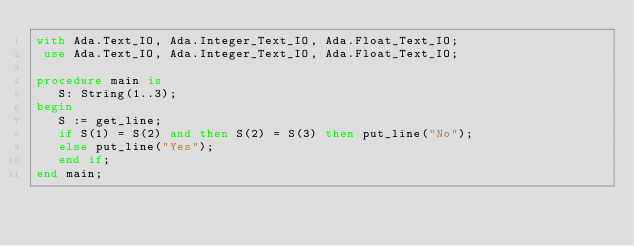Convert code to text. <code><loc_0><loc_0><loc_500><loc_500><_Ada_>with Ada.Text_IO, Ada.Integer_Text_IO, Ada.Float_Text_IO;
 use Ada.Text_IO, Ada.Integer_Text_IO, Ada.Float_Text_IO;

procedure main is
   S: String(1..3);
begin
   S := get_line;
   if S(1) = S(2) and then S(2) = S(3) then put_line("No");
   else put_line("Yes");
   end if;
end main;</code> 